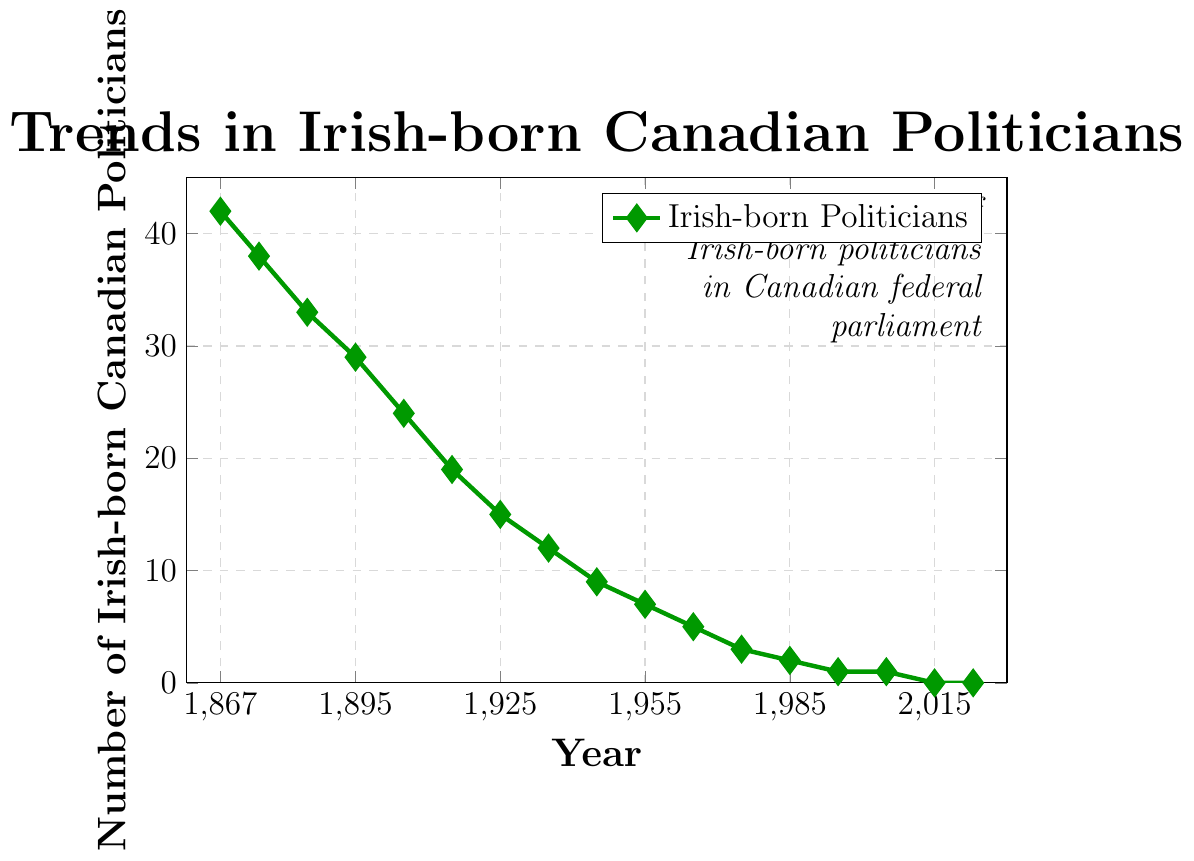How many Irish-born Canadian politicians were in federal parliament in 1867, and how many were there in 2023? By simply looking at the figure, we can observe the data points for the years 1867 and 2023. The number of Irish-born Canadian politicians in 1867 was 42, and in 2023 it was 0.
Answer: 42 in 1867 and 0 in 2023 In which decade did the number of Irish-born Canadian politicians drop the most significantly? To determine the decade with the most significant drop, we need to compare the differences between consecutive data points for each decade. The largest drop occurred from 1867 to 1875, where the number decreased from 42 to 38 (a drop of 4).
Answer: 1860s to 1870s What is the average number of Irish-born Canadian politicians from 1867 to 2023? To calculate the average, sum all the data points (42 + 38 + 33 + 29 + 24 + 19 + 15 + 12 + 9 + 7 + 5 + 3 + 2 + 1 + 1 + 0 + 0 = 238) and divide by the number of years listed (17). The average is 238 / 17.
Answer: 14 During which time period did the number of Irish-born Canadian politicians remain the same? The number remained the same between 2005 and 2015, where it stayed at 1, and between 2015 and 2023, where it remained at 0.
Answer: 2005-2015 and 2015-2023 What trend can be observed in the number of Irish-born Canadian politicians from Confederation to present? The general trend observed from the line chart shows a steady decline in the number of Irish-born Canadian politicians from 42 in 1867 to 0 in recent years.
Answer: Steady decline By what factor did the number of Irish-born Canadian politicians decrease from 1867 to 1925? To find the factor, divide the number of politicians in 1867 by the number in 1925 (42 / 15 = 2.8). So, the number decreased by a factor of 2.8.
Answer: 2.8 Compare the number of Irish-born Canadian politicians in 1945 and 1965. Which year had more and by how much? Referring to the figure, 1945 had 9 politicians, and 1965 had 5. 1945 had 4 more politicians than 1965.
Answer: 1945 had 4 more What is the median number of Irish-born Canadian politicians for the data provided? To find the median, arrange the values in ascending order: 0, 0, 1, 1, 2, 3, 5, 7, 9, 12, 15, 19, 24, 29, 33, 38, 42. The median is the middle value, so the 9th value, which is 9.
Answer: 9 Which year had the highest number of Irish-born Canadian politicians? Observing the highest data point on the graph, the year 1867 had the highest number of Irish-born Canadian politicians, which was 42.
Answer: 1867 How has the number of Irish-born Canadian politicians changed from 1985 to 1995? Observing the chart, the number decreased from 2 in 1985 to 1 in 1995, showing a decrease of 1.
Answer: Decreased by 1 What is the difference between the number of Irish-born Canadian politicians in 1875 and 1885? The chart shows that there were 38 politicians in 1875 and 33 in 1885. Subtracting these numbers gives 38 - 33 = 5.
Answer: 5 